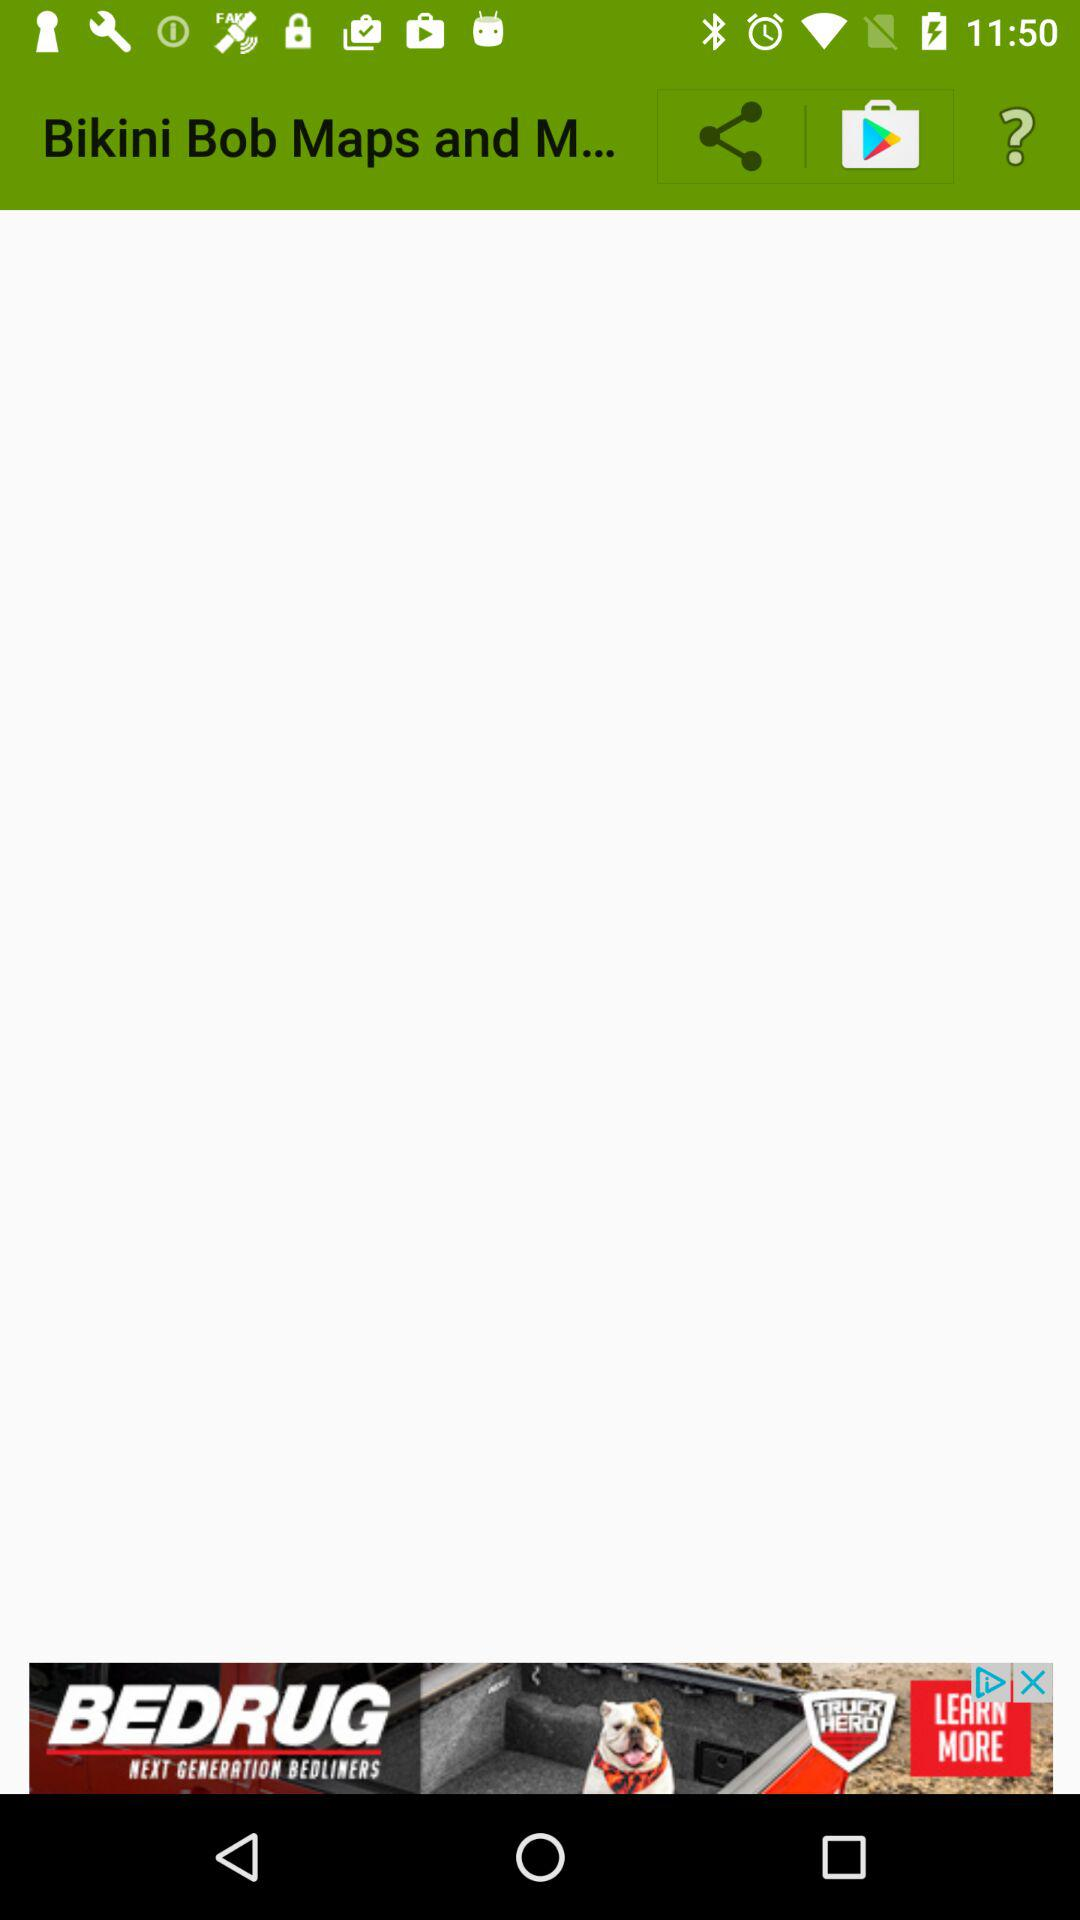What is the application name? The application name is "Bikini Bob Maps and M...". 